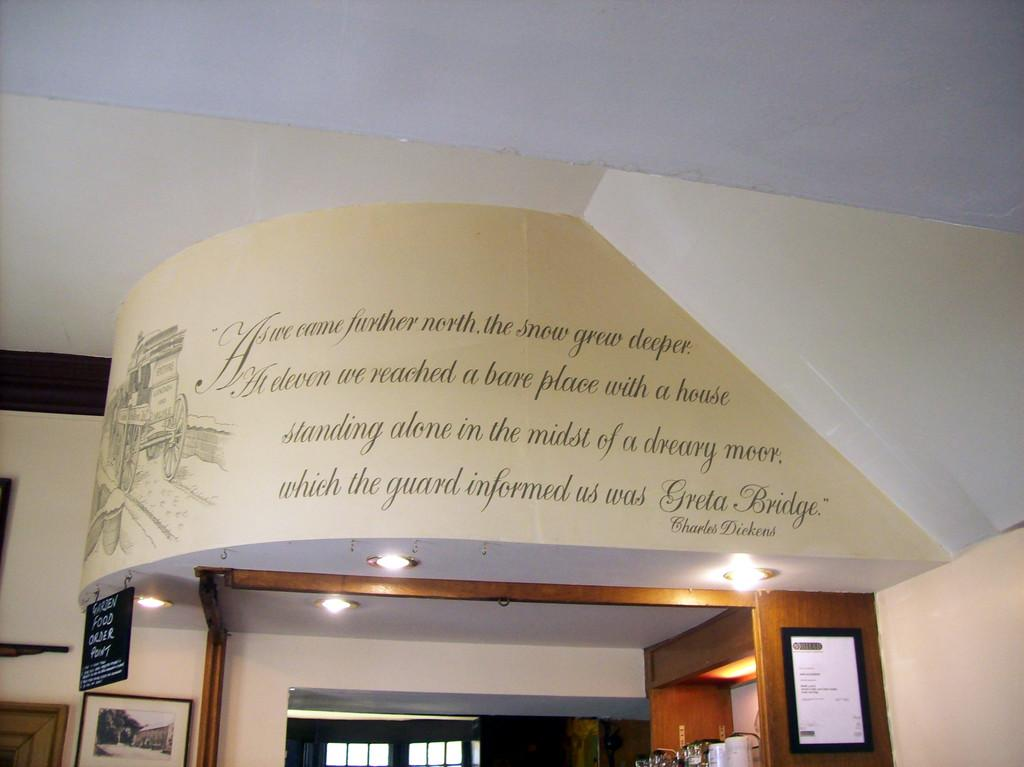What type of illumination is present in the image? There are lights in the image. What type of decorative or framed items can be seen in the image? There are frames in the image. What type of signage is present in the image? There is a name board in the image. What type of architectural feature is present in the image? There is a window in the image. What type of storage or display item is present in the image? There is a cart in the image. What type of container is present in the image? There is a basket in the image. What type of path or walkway is present in the image? There is a path in the image. What type of text or label is present in the image? There is some text on an object in the image. What other objects or items can be seen in the image? There are additional objects in the image. What type of cake is being protested in the image? There is no cake or protest present in the image. What type of crib is visible in the image? There is no crib present in the image. 